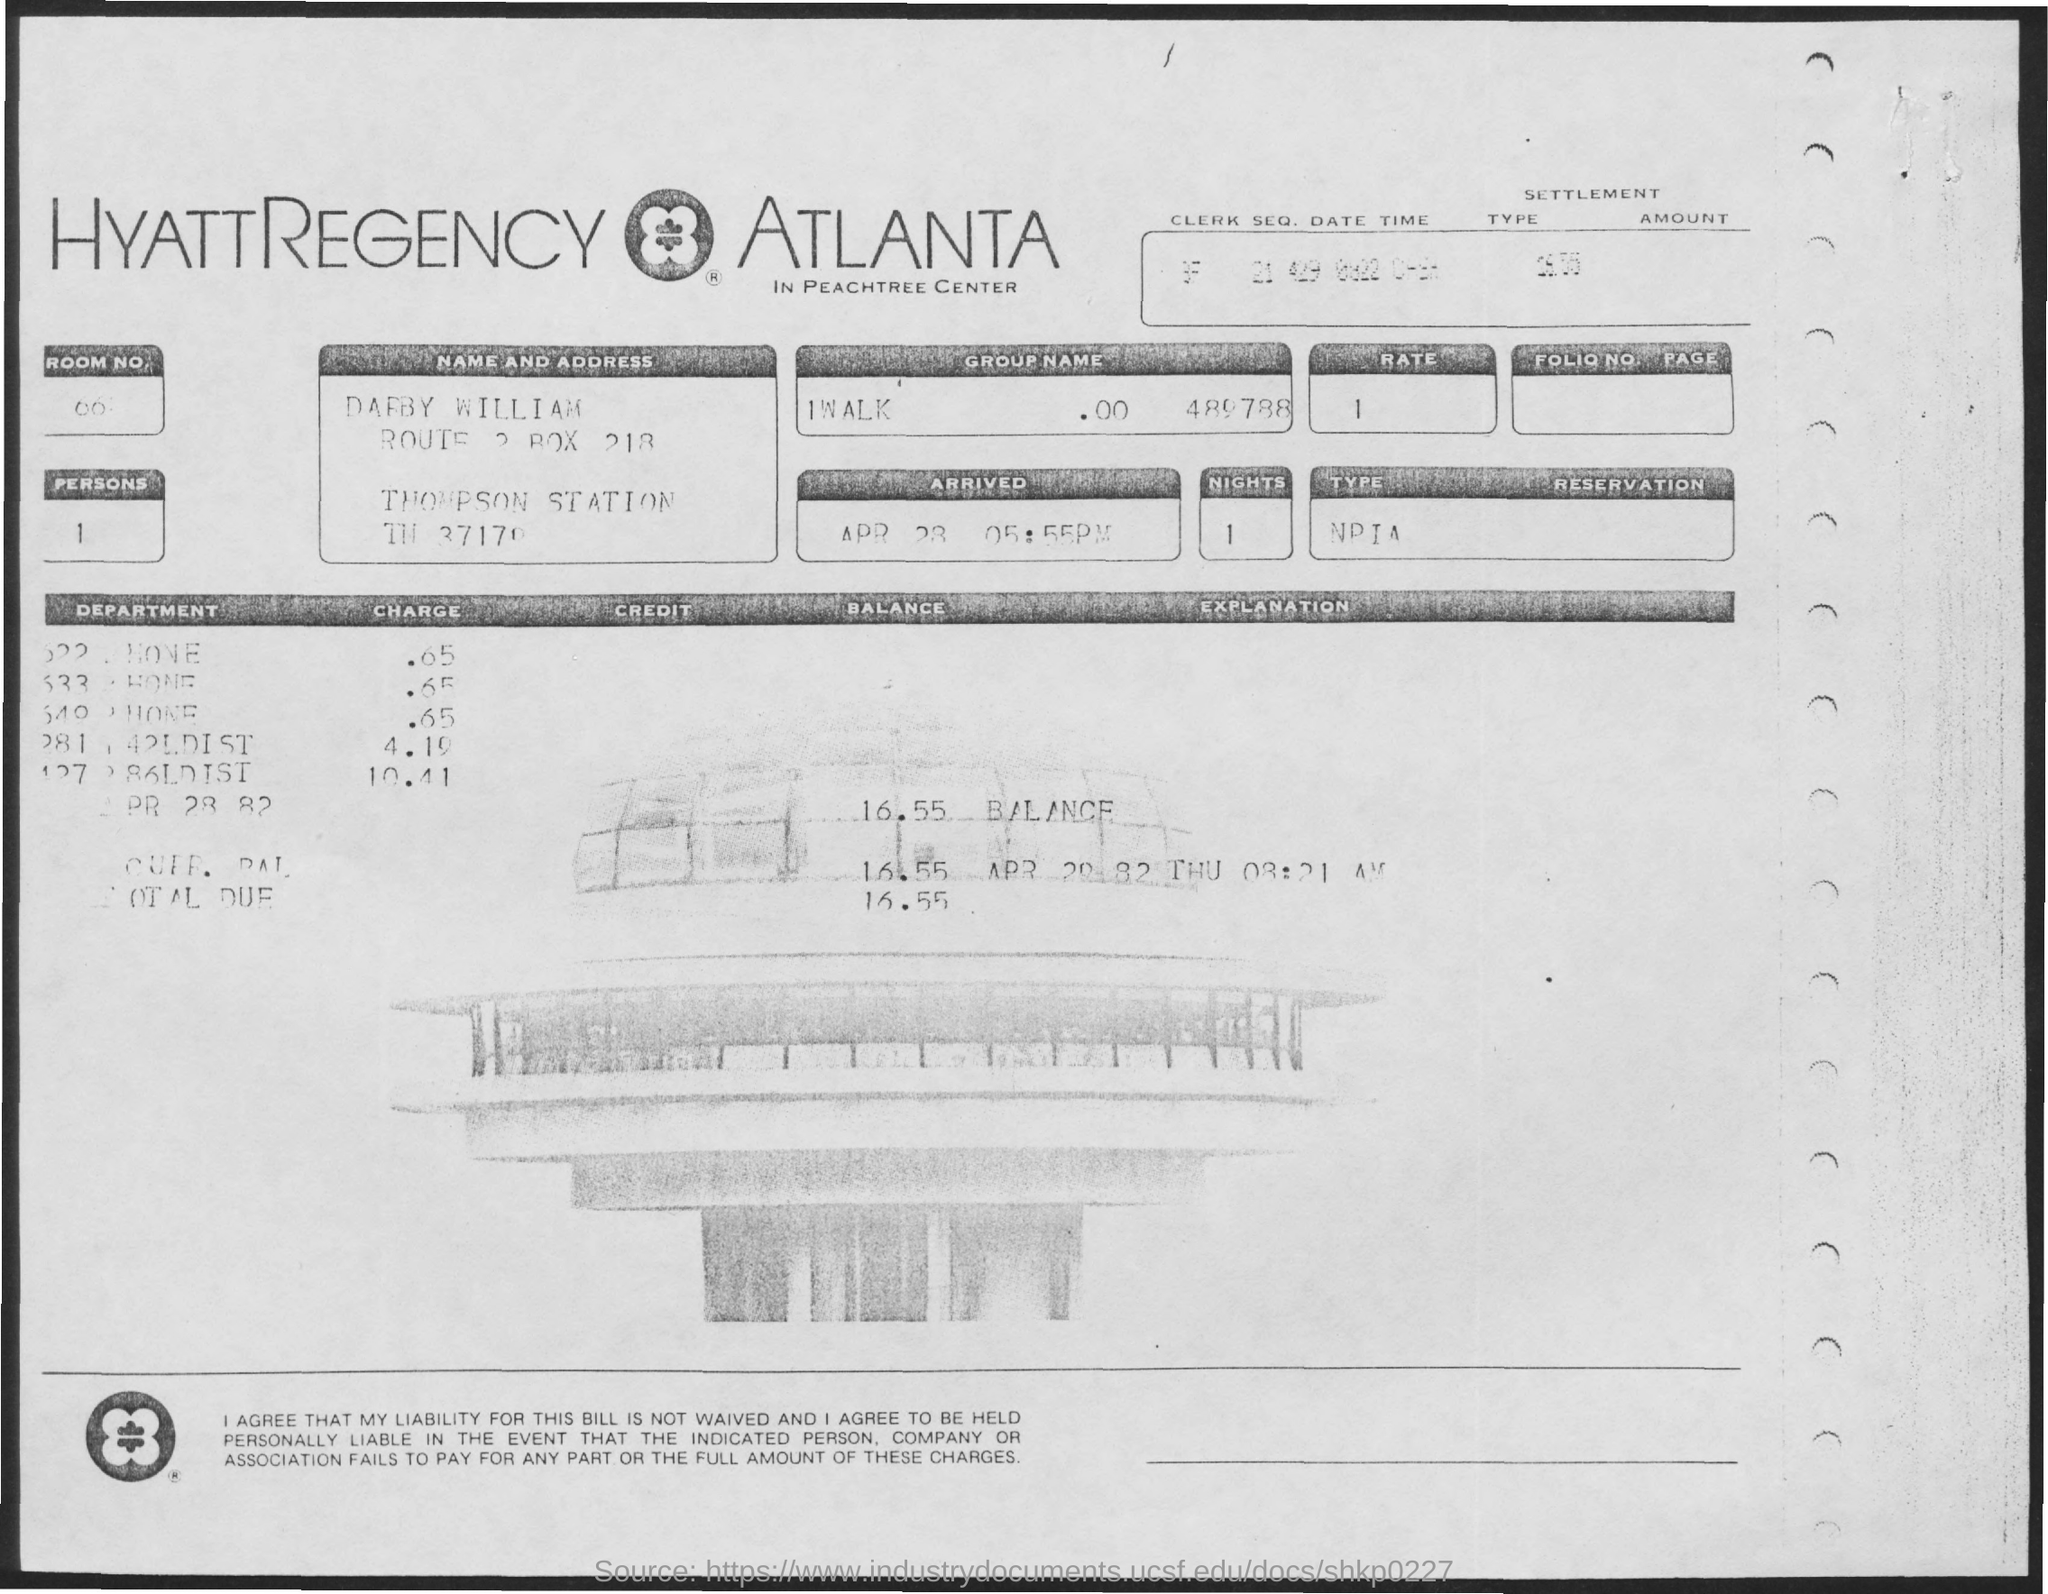Highlight a few significant elements in this photo. The number of nights is 1. There is a person. I would like to inquire about the rate for a rental property with the specifications of 1 bedroom and 1 bathroom, located in a desirable neighborhood, with a budget of $1500 per month. The name of the person is Darby William. 